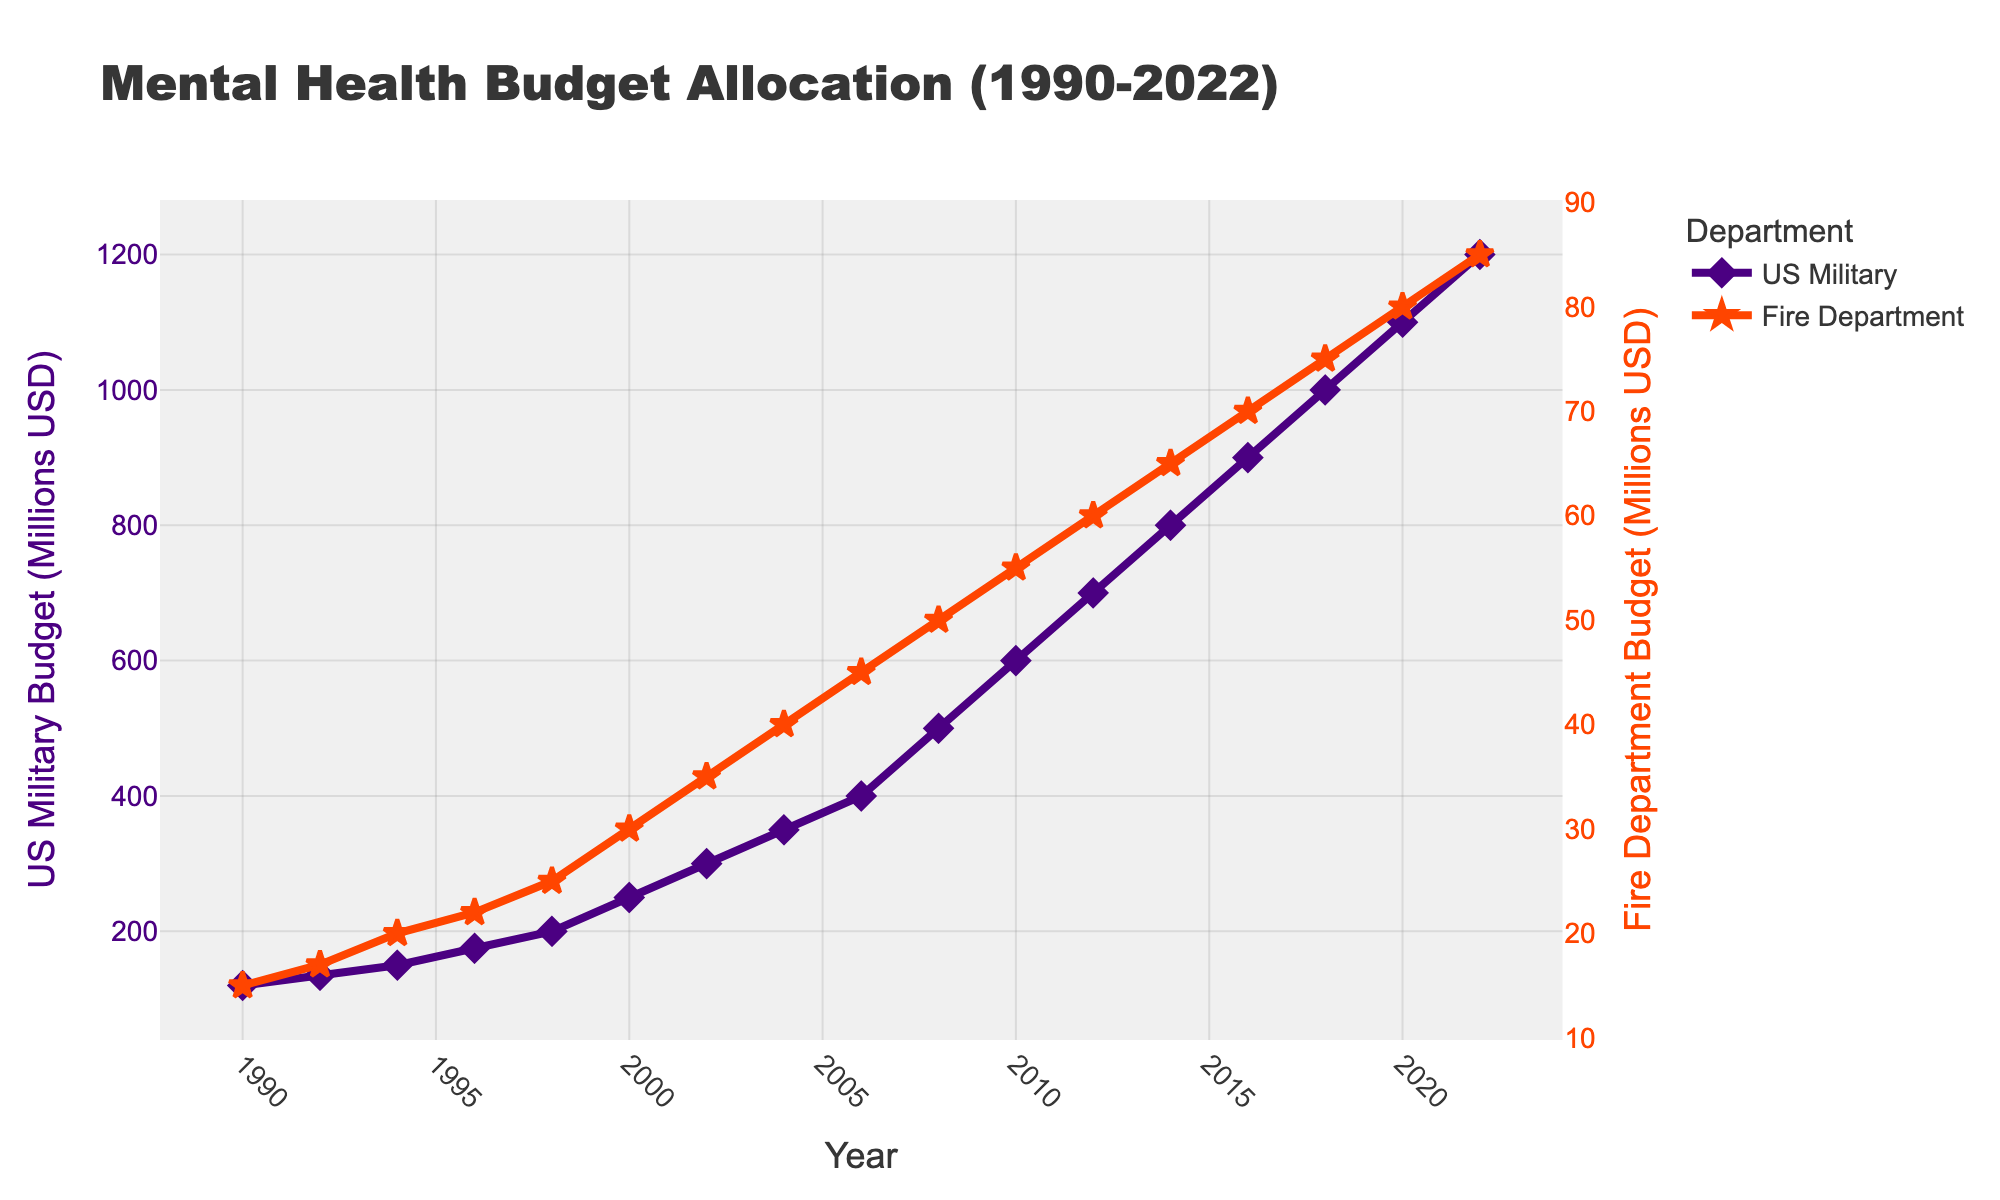What's the difference in the US Military Mental Health Budget between 1990 and 2022? To find the difference, subtract the 1990 budget from the 2022 budget: 1200 million USD (2022) - 120 million USD (1990) = 1080 million USD
Answer: 1080 million USD In which year did the Fire Department's Mental Health Budget first exceed 50 million USD? Refer to the plot and look for the first point where the budget for the Fire Department surpasses 50 million USD. This occurs in 2008 when the budget reaches 50 million USD
Answer: 2008 What is the total increase in the Fire Department Mental Health Budget from 1990 to 2022? Subtract the 1990 budget from the 2022 budget: 85 million USD (2022) - 15 million USD (1990) = 70 million USD
Answer: 70 million USD Which department had a steeper increase in Mental Health Budget from 2010 to 2020? Compare the slopes of the lines between these years. For the US Military: 1100 million USD (2020) - 600 million USD (2010) = 500 million USD increase. For the Fire Department: 80 million USD (2020) - 55 million USD (2010) = 25 million USD increase. The US Military had a steeper increase.
Answer: US Military In which year did the US Military budget first exceed 700 million USD? Refer to the US Military line on the plot and find the first year where the budget exceeds 700 million USD. This happens in 2012
Answer: 2012 What's the average annual budget for the US Military from 1990 to 2022? Sum up all the budget values for the US Military from 1990 to 2022 and divide by the number of years (17 data points): (120 + 135 + 150 + 175 + 200 + 250 + 300 + 350 + 400 + 500 + 600 + 700 + 800 + 900 + 1000 + 1100 + 1200) / 17 = 4882 / 17 ≈ 287.18 million USD
Answer: 287.18 million USD What's the total combined budget for both departments in the year 2000? Add the budgets for both departments in 2000: 250 million USD (US Military) + 30 million USD (Fire Department) = 280 million USD
Answer: 280 million USD Compare the budget increments for US Military Mental Health between 2000-2010 and 2012-2022. Which period saw a greater increment? For 2000-2010: 600 million USD (2010) - 250 million USD (2000) = 350 million USD increment. For 2012-2022: 1200 million USD (2022) - 700 million USD (2012) = 500 million USD increment. The 2012-2022 period saw a greater increment.
Answer: 2012-2022 Is there any year where the Fire Department budget decreases as compared to the previous year? Check each point in the Fire Department line for a decrease from the previous year. Upon examining the plot, there are no years where the Fire Department budget decreases compared to the previous year.
Answer: No 